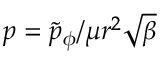Convert formula to latex. <formula><loc_0><loc_0><loc_500><loc_500>p = \widetilde { p } _ { \phi } / \mu r ^ { 2 } \sqrt { \beta }</formula> 